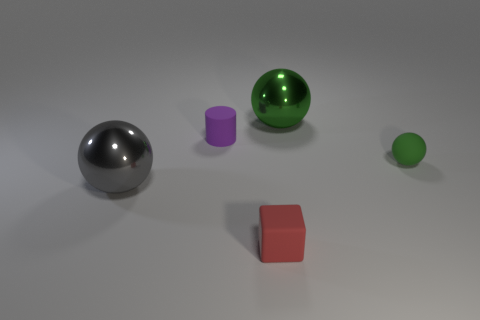Add 1 green rubber cylinders. How many objects exist? 6 Subtract all balls. How many objects are left? 2 Subtract 0 yellow blocks. How many objects are left? 5 Subtract all tiny purple objects. Subtract all small objects. How many objects are left? 1 Add 3 rubber cubes. How many rubber cubes are left? 4 Add 1 yellow matte cubes. How many yellow matte cubes exist? 1 